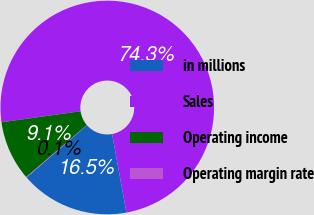Convert chart. <chart><loc_0><loc_0><loc_500><loc_500><pie_chart><fcel>in millions<fcel>Sales<fcel>Operating income<fcel>Operating margin rate<nl><fcel>16.5%<fcel>74.33%<fcel>9.07%<fcel>0.09%<nl></chart> 